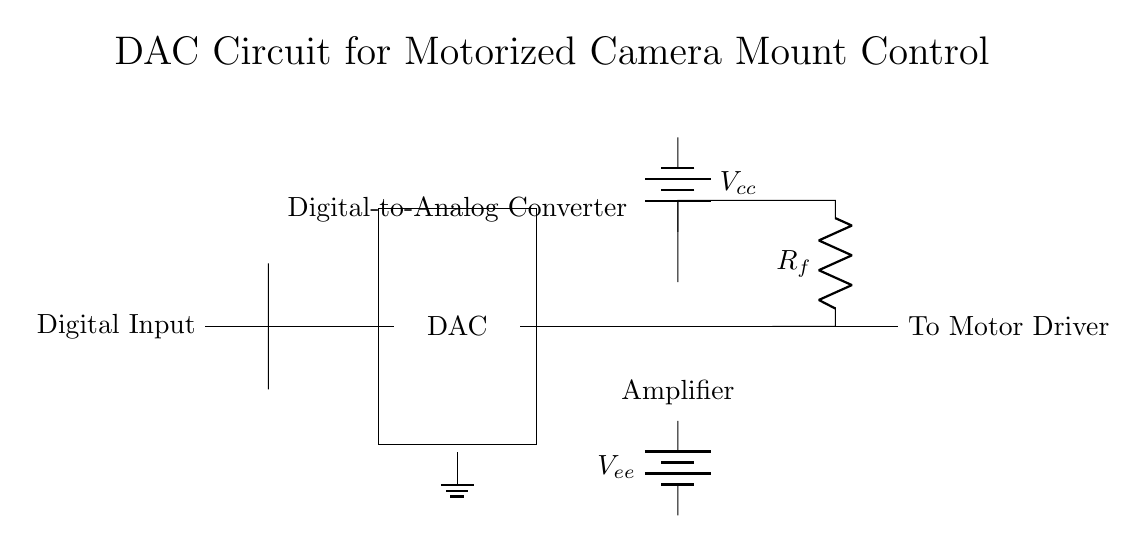What is the type of output from the DAC? The output from the DAC is an analog signal, which is generated from the digital input to control the motorized camera mount.
Answer: Analog signal What is the role of the op-amp in this circuit? The op-amp functions as an amplifier, increasing the strength of the signal fed into the motor driver's input.
Answer: Amplifier What is the function of R_f in the circuit? R_f is a feedback resistor that helps control the gain of the op-amp, determining how much the output signal is amplified.
Answer: Feedback resistor What supplies power to the circuit? The circuit is powered by two batteries labeled as V_cc for positive voltage and V_ee for negative voltage, providing the necessary power for operation.
Answer: Batteries What is the relationship between the digital input and the output to the motor driver? The digital input directly controls the analog output generated by the DAC, which is then transmitted to the motor driver to move the camera mount.
Answer: Direct control 